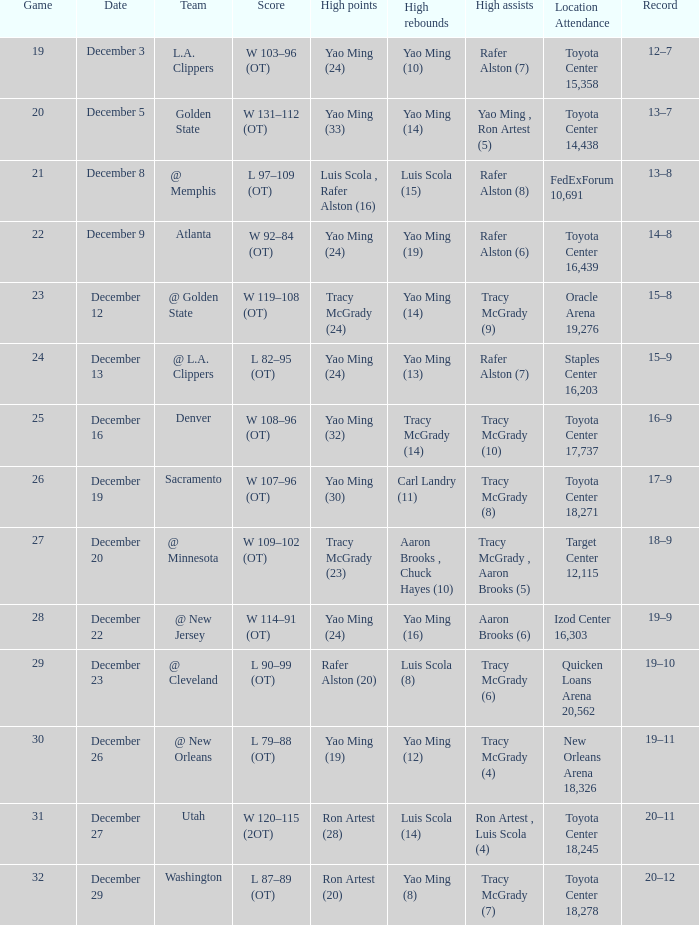When tracy mcgrady (8) is ahead in assists, what is the date? December 19. 